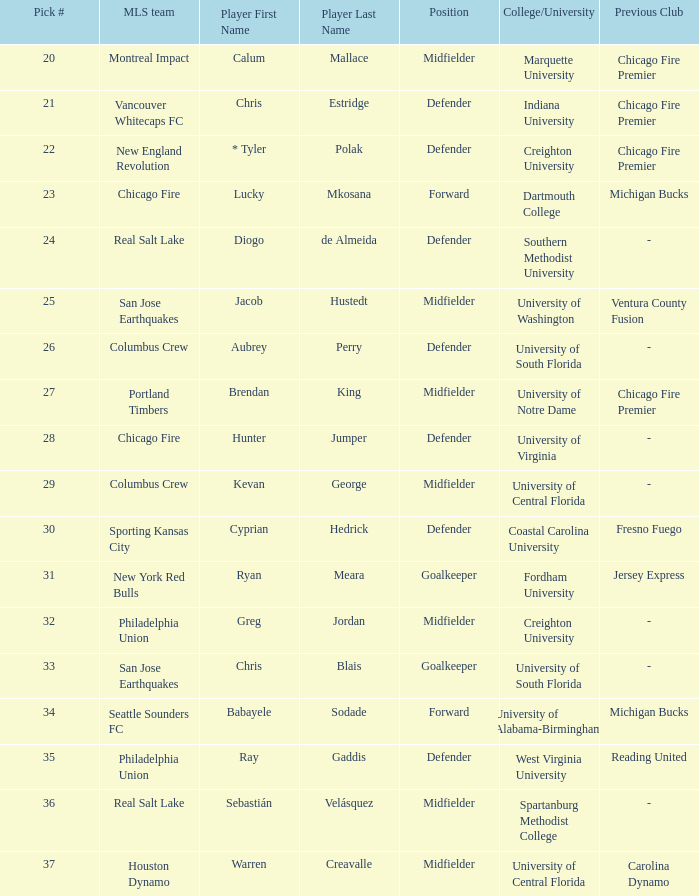What pick number is Kevan George? 29.0. 